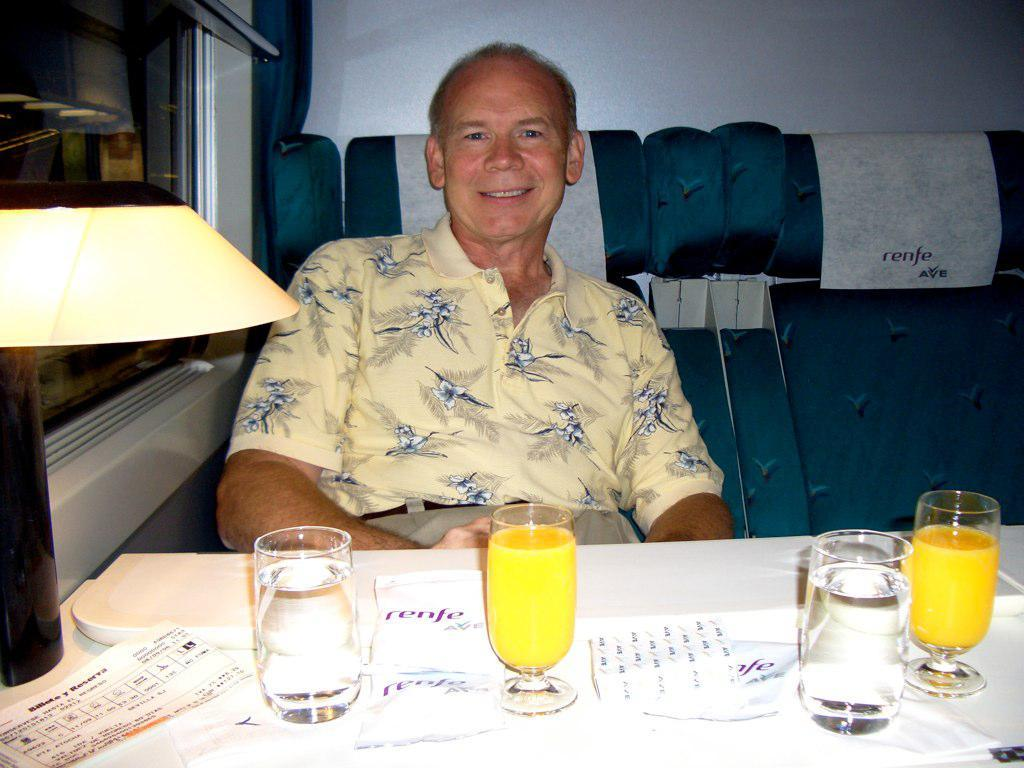What is the person in the image doing? The person is sitting on a seat in the image. What objects are on the table in the image? There are glasses, papers, and a lamp on the table in the image. What type of window is visible in the image? There is a glass window visible in the image. What color is the wall in the image? The wall in the image is white-colored. Can you see a stranger covering the sand in the image? There is no stranger, sand, or covering activity present in the image. 